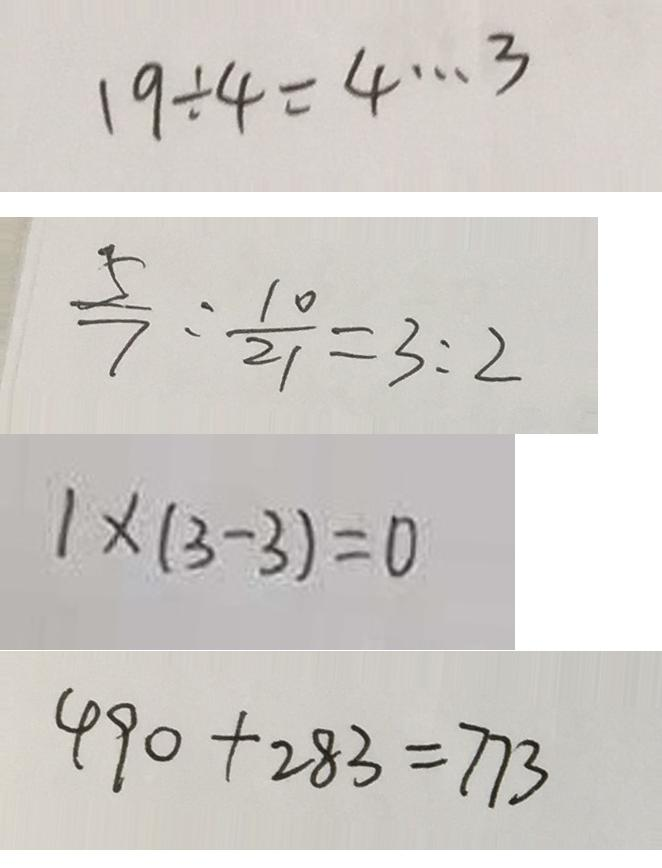Convert formula to latex. <formula><loc_0><loc_0><loc_500><loc_500>1 9 \div 4 = 4 \cdots 3 
 \frac { 5 } { 7 } : \frac { 1 0 } { 2 1 } = 3 : 2 
 1 \times ( 3 - 3 ) = 0 
 4 9 0 + 2 8 3 = 7 7 3</formula> 